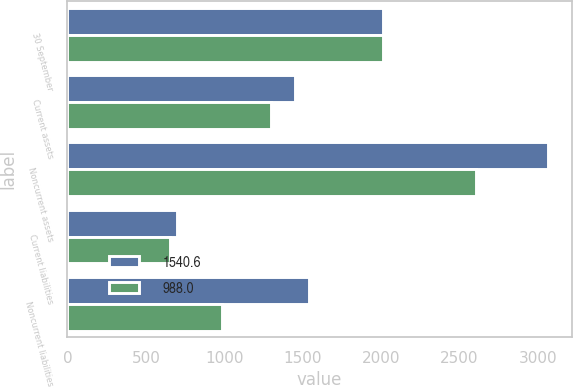Convert chart to OTSL. <chart><loc_0><loc_0><loc_500><loc_500><stacked_bar_chart><ecel><fcel>30 September<fcel>Current assets<fcel>Noncurrent assets<fcel>Current liabilities<fcel>Noncurrent liabilities<nl><fcel>1540.6<fcel>2016<fcel>1449.8<fcel>3063.9<fcel>699.2<fcel>1540.6<nl><fcel>988<fcel>2015<fcel>1296.4<fcel>2607.4<fcel>654<fcel>988<nl></chart> 